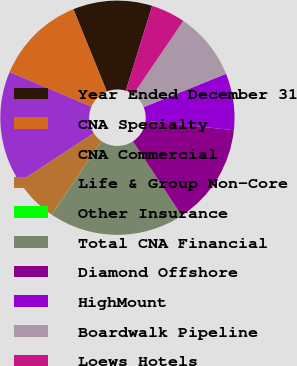Convert chart to OTSL. <chart><loc_0><loc_0><loc_500><loc_500><pie_chart><fcel>Year Ended December 31<fcel>CNA Specialty<fcel>CNA Commercial<fcel>Life & Group Non-Core<fcel>Other Insurance<fcel>Total CNA Financial<fcel>Diamond Offshore<fcel>HighMount<fcel>Boardwalk Pipeline<fcel>Loews Hotels<nl><fcel>10.93%<fcel>12.49%<fcel>15.61%<fcel>6.26%<fcel>0.03%<fcel>18.72%<fcel>14.05%<fcel>7.82%<fcel>9.38%<fcel>4.71%<nl></chart> 